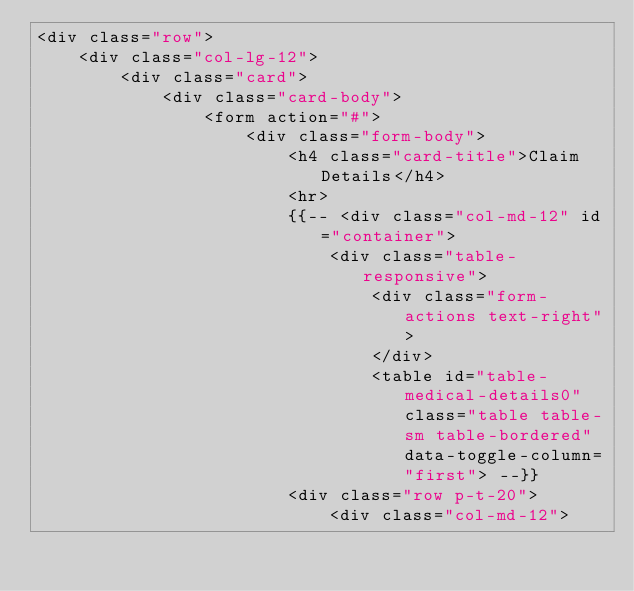Convert code to text. <code><loc_0><loc_0><loc_500><loc_500><_PHP_><div class="row">
    <div class="col-lg-12">
        <div class="card">
            <div class="card-body">
                <form action="#">
                    <div class="form-body">
                        <h4 class="card-title">Claim Details</h4>
                        <hr>
                        {{-- <div class="col-md-12" id="container">
                            <div class="table-responsive">
                                <div class="form-actions text-right">
                                </div>
                                <table id="table-medical-details0" class="table table-sm table-bordered" data-toggle-column="first"> --}}
                        <div class="row p-t-20">
                            <div class="col-md-12"></code> 